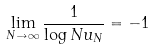<formula> <loc_0><loc_0><loc_500><loc_500>\lim _ { N \to \infty } \frac { 1 } { \log N u _ { N } } = - 1</formula> 